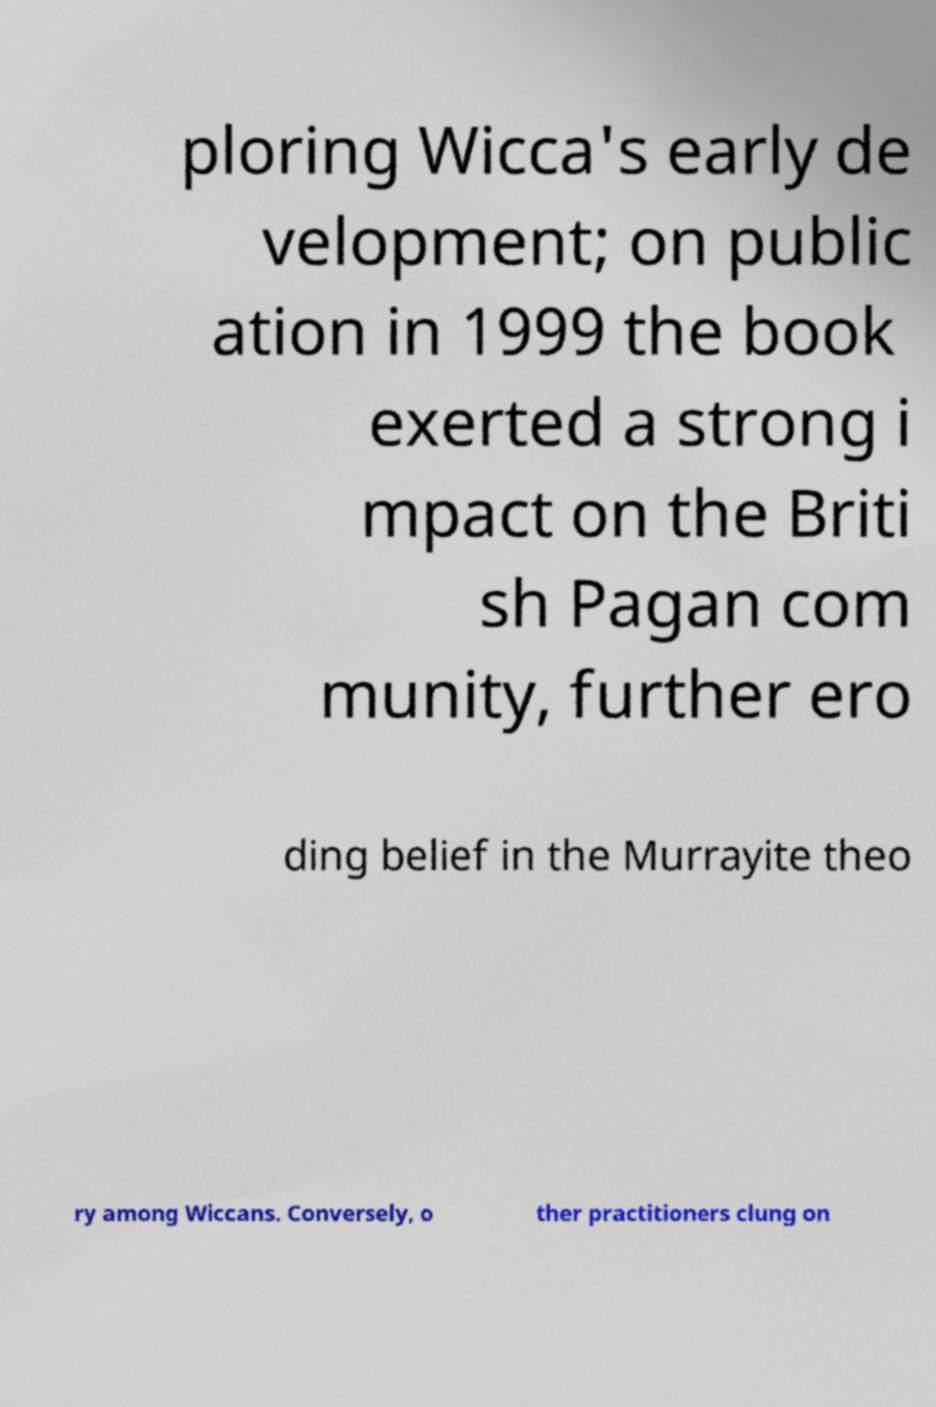Please read and relay the text visible in this image. What does it say? ploring Wicca's early de velopment; on public ation in 1999 the book exerted a strong i mpact on the Briti sh Pagan com munity, further ero ding belief in the Murrayite theo ry among Wiccans. Conversely, o ther practitioners clung on 